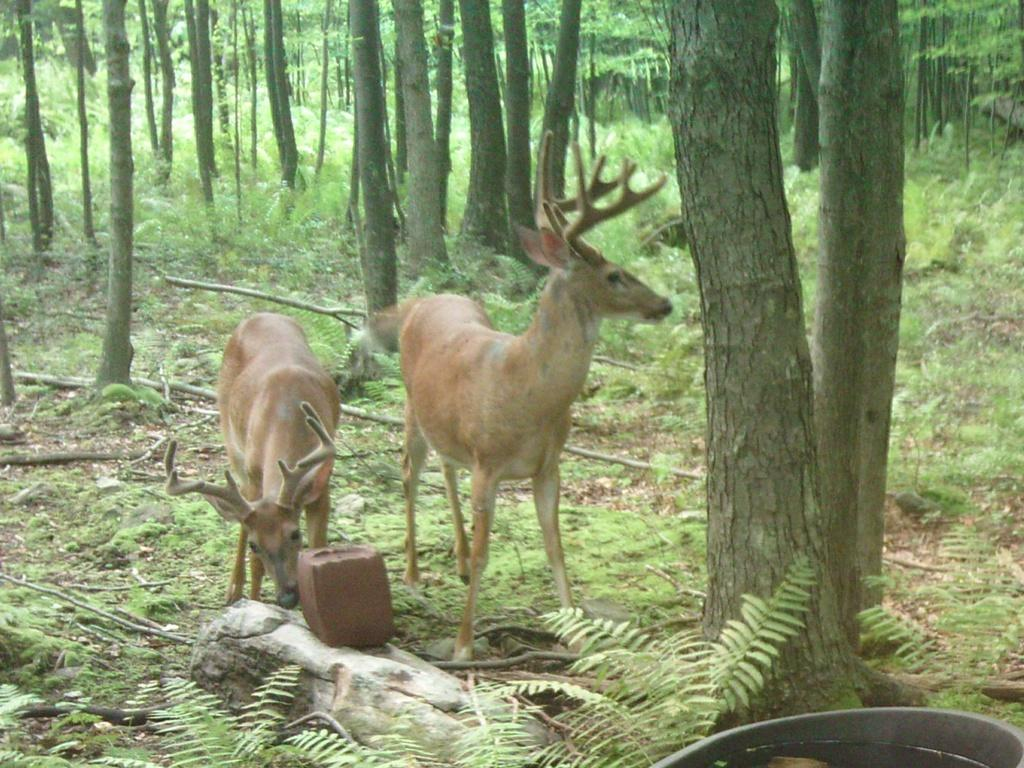How many animals are present in the image? There are two animals in the image. What are the animals doing in the image? The animals are standing. What color are the animals in the image? The animals are brown in color. What can be seen in the background of the image? There are trees in the background of the image. What color are the trees in the image? The trees are green in color. Can the animals be seen swimming in the image? No, the animals are standing in the image, and there is no indication of them swimming. 